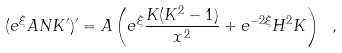Convert formula to latex. <formula><loc_0><loc_0><loc_500><loc_500>( e ^ { \xi } A N K ^ { \prime } ) ^ { \prime } = A \left ( e ^ { \xi } \frac { K ( K ^ { 2 } - 1 ) } { x ^ { 2 } } + e ^ { - 2 \xi } H ^ { 2 } K \right ) \ ,</formula> 